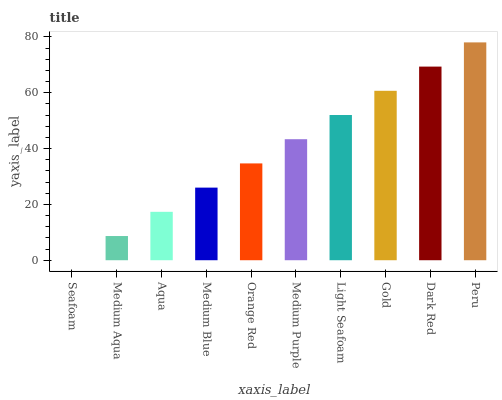Is Seafoam the minimum?
Answer yes or no. Yes. Is Peru the maximum?
Answer yes or no. Yes. Is Medium Aqua the minimum?
Answer yes or no. No. Is Medium Aqua the maximum?
Answer yes or no. No. Is Medium Aqua greater than Seafoam?
Answer yes or no. Yes. Is Seafoam less than Medium Aqua?
Answer yes or no. Yes. Is Seafoam greater than Medium Aqua?
Answer yes or no. No. Is Medium Aqua less than Seafoam?
Answer yes or no. No. Is Medium Purple the high median?
Answer yes or no. Yes. Is Orange Red the low median?
Answer yes or no. Yes. Is Orange Red the high median?
Answer yes or no. No. Is Peru the low median?
Answer yes or no. No. 